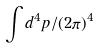<formula> <loc_0><loc_0><loc_500><loc_500>\int d ^ { 4 } p / ( 2 \pi ) ^ { 4 }</formula> 